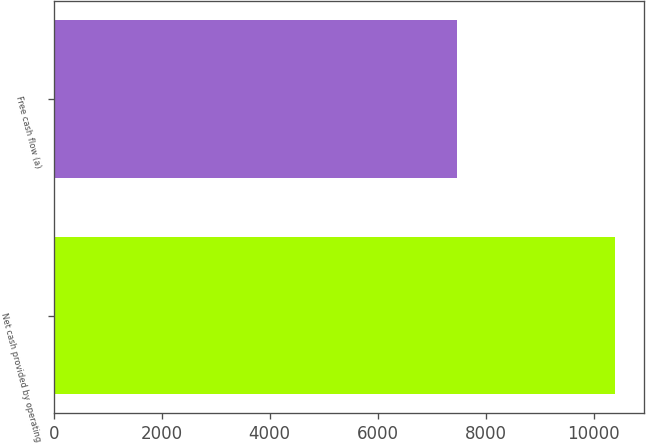Convert chart. <chart><loc_0><loc_0><loc_500><loc_500><bar_chart><fcel>Net cash provided by operating<fcel>Free cash flow (a)<nl><fcel>10404<fcel>7463<nl></chart> 